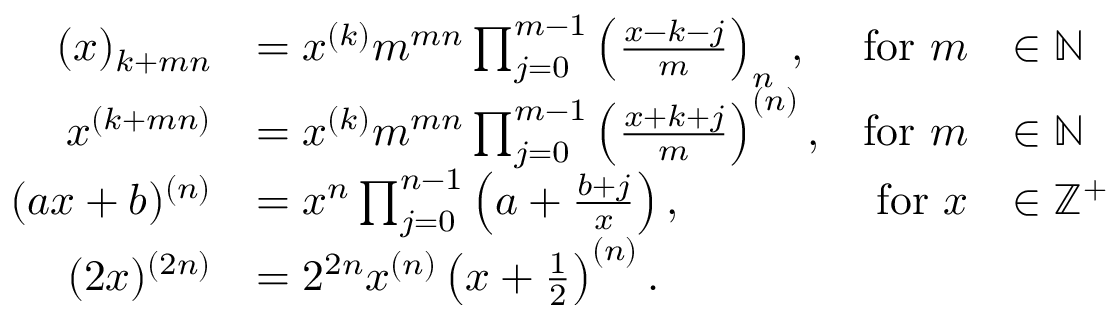Convert formula to latex. <formula><loc_0><loc_0><loc_500><loc_500>{ \begin{array} { r l r l } { ( x ) _ { k + m n } } & { = x ^ { ( k ) } m ^ { m n } \prod _ { j = 0 } ^ { m - 1 } \left ( { \frac { x - k - j } { m } } \right ) _ { n } \, , } & { { f o r } m } & { \in \mathbb { N } } \\ { x ^ { ( k + m n ) } } & { = x ^ { ( k ) } m ^ { m n } \prod _ { j = 0 } ^ { m - 1 } \left ( { \frac { x + k + j } { m } } \right ) ^ { ( n ) } , } & { { f o r } m } & { \in \mathbb { N } } \\ { ( a x + b ) ^ { ( n ) } } & { = x ^ { n } \prod _ { j = 0 } ^ { n - 1 } \left ( a + { \frac { b + j } { x } } \right ) , } & { { f o r } x } & { \in \mathbb { Z } ^ { + } } \\ { ( 2 x ) ^ { ( 2 n ) } } & { = 2 ^ { 2 n } x ^ { ( n ) } \left ( x + { \frac { 1 } { 2 } } \right ) ^ { ( n ) } . } \end{array} }</formula> 